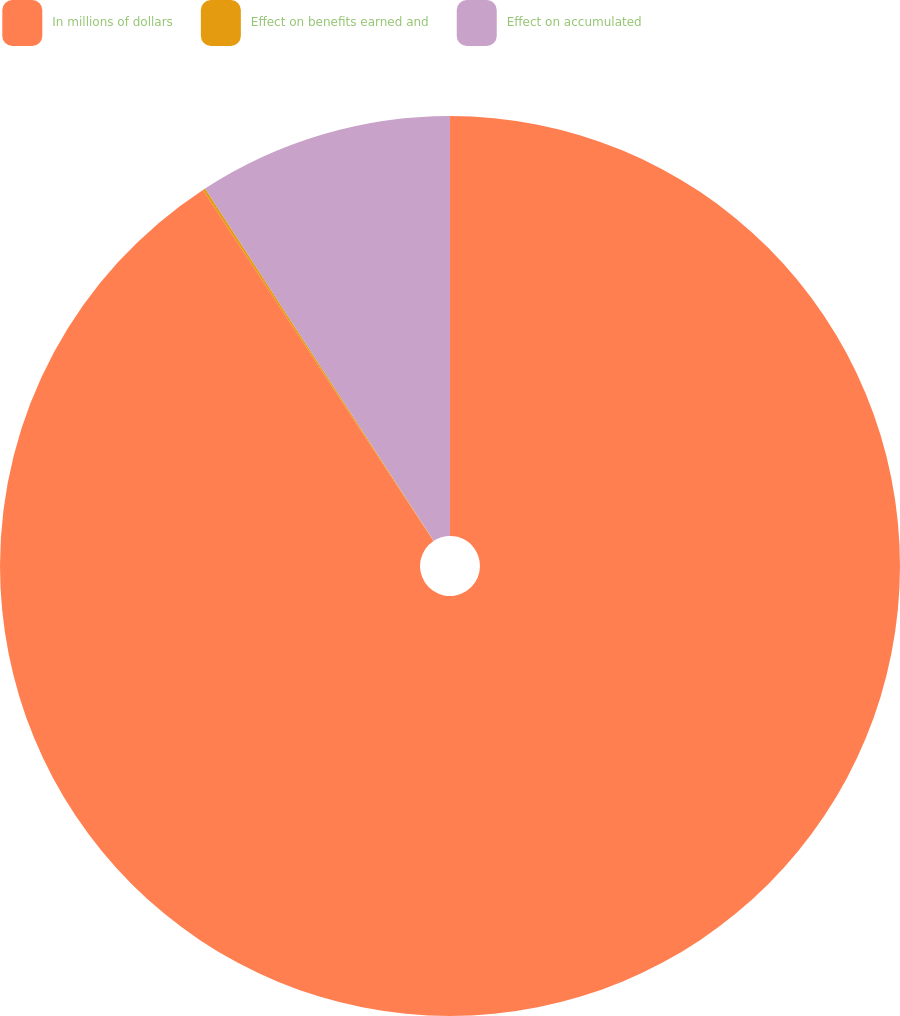Convert chart. <chart><loc_0><loc_0><loc_500><loc_500><pie_chart><fcel>In millions of dollars<fcel>Effect on benefits earned and<fcel>Effect on accumulated<nl><fcel>90.75%<fcel>0.09%<fcel>9.16%<nl></chart> 